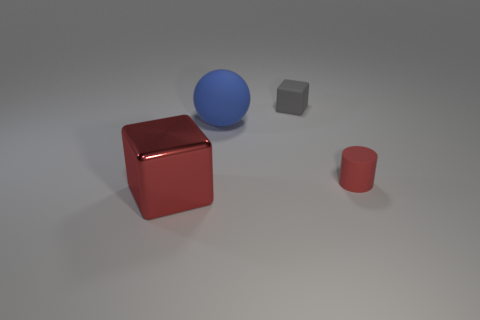Add 4 big blue objects. How many objects exist? 8 Subtract all spheres. How many objects are left? 3 Subtract all tiny red cubes. Subtract all large blue spheres. How many objects are left? 3 Add 3 matte cylinders. How many matte cylinders are left? 4 Add 1 cylinders. How many cylinders exist? 2 Subtract 1 blue balls. How many objects are left? 3 